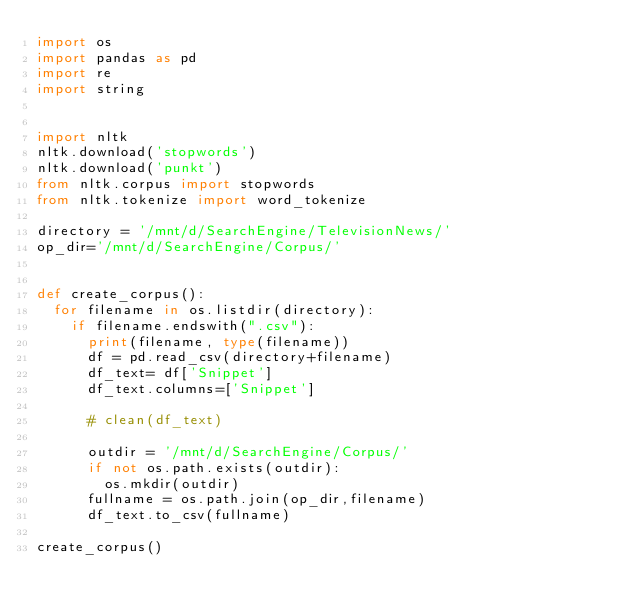<code> <loc_0><loc_0><loc_500><loc_500><_Python_>import os
import pandas as pd
import re
import string


import nltk
nltk.download('stopwords')
nltk.download('punkt')
from nltk.corpus import stopwords
from nltk.tokenize import word_tokenize

directory = '/mnt/d/SearchEngine/TelevisionNews/'
op_dir='/mnt/d/SearchEngine/Corpus/'


def create_corpus():
	for filename in os.listdir(directory):
		if filename.endswith(".csv"):
			print(filename, type(filename))
			df = pd.read_csv(directory+filename)
			df_text= df['Snippet']
			df_text.columns=['Snippet']

			# clean(df_text)

			outdir = '/mnt/d/SearchEngine/Corpus/'
			if not os.path.exists(outdir):
				os.mkdir(outdir)
			fullname = os.path.join(op_dir,filename)
			df_text.to_csv(fullname)

create_corpus()</code> 